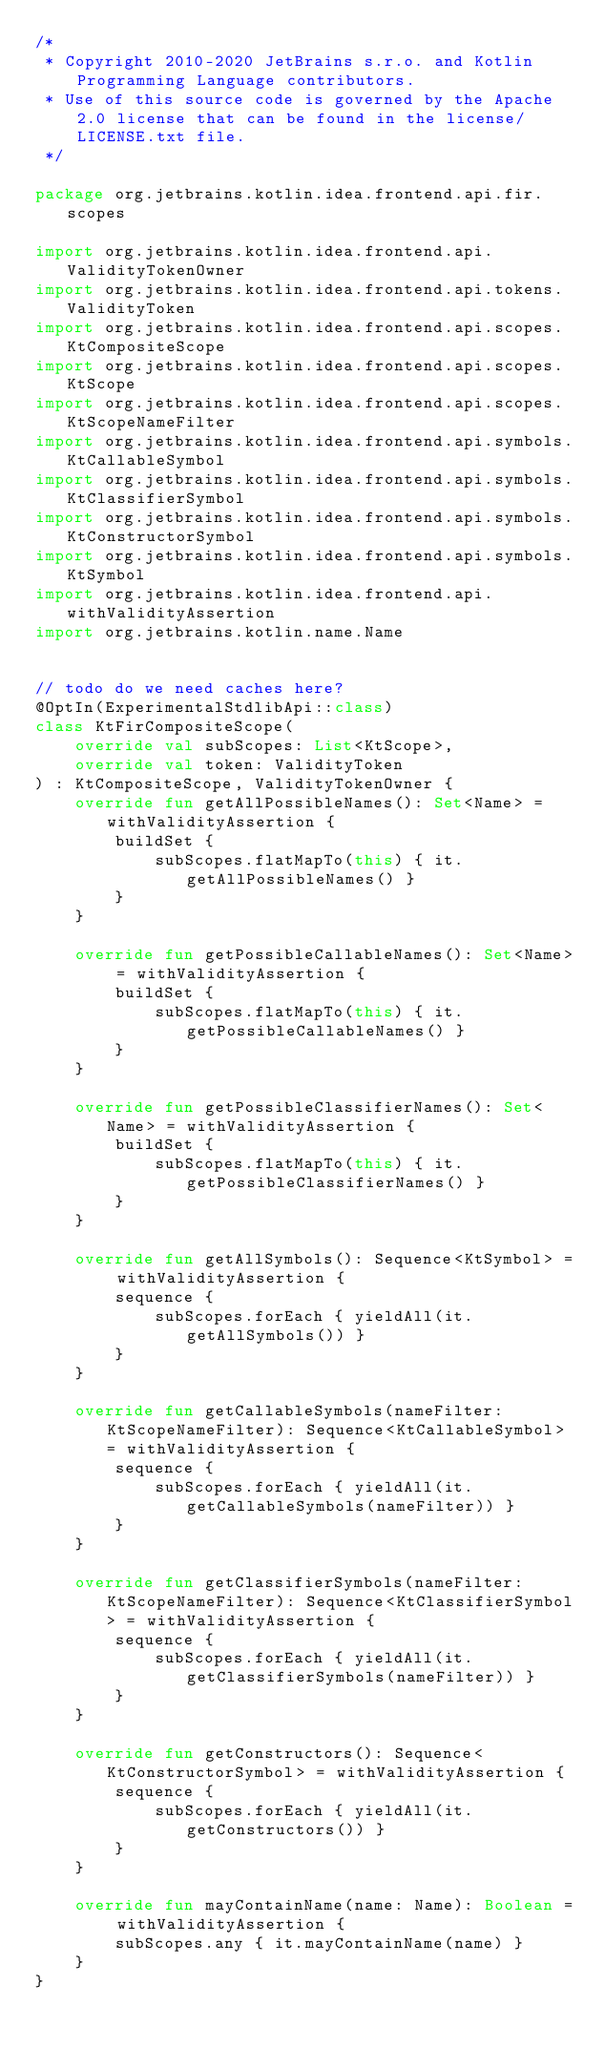Convert code to text. <code><loc_0><loc_0><loc_500><loc_500><_Kotlin_>/*
 * Copyright 2010-2020 JetBrains s.r.o. and Kotlin Programming Language contributors.
 * Use of this source code is governed by the Apache 2.0 license that can be found in the license/LICENSE.txt file.
 */

package org.jetbrains.kotlin.idea.frontend.api.fir.scopes

import org.jetbrains.kotlin.idea.frontend.api.ValidityTokenOwner
import org.jetbrains.kotlin.idea.frontend.api.tokens.ValidityToken
import org.jetbrains.kotlin.idea.frontend.api.scopes.KtCompositeScope
import org.jetbrains.kotlin.idea.frontend.api.scopes.KtScope
import org.jetbrains.kotlin.idea.frontend.api.scopes.KtScopeNameFilter
import org.jetbrains.kotlin.idea.frontend.api.symbols.KtCallableSymbol
import org.jetbrains.kotlin.idea.frontend.api.symbols.KtClassifierSymbol
import org.jetbrains.kotlin.idea.frontend.api.symbols.KtConstructorSymbol
import org.jetbrains.kotlin.idea.frontend.api.symbols.KtSymbol
import org.jetbrains.kotlin.idea.frontend.api.withValidityAssertion
import org.jetbrains.kotlin.name.Name


// todo do we need caches here?
@OptIn(ExperimentalStdlibApi::class)
class KtFirCompositeScope(
    override val subScopes: List<KtScope>,
    override val token: ValidityToken
) : KtCompositeScope, ValidityTokenOwner {
    override fun getAllPossibleNames(): Set<Name> = withValidityAssertion {
        buildSet {
            subScopes.flatMapTo(this) { it.getAllPossibleNames() }
        }
    }

    override fun getPossibleCallableNames(): Set<Name> = withValidityAssertion {
        buildSet {
            subScopes.flatMapTo(this) { it.getPossibleCallableNames() }
        }
    }

    override fun getPossibleClassifierNames(): Set<Name> = withValidityAssertion {
        buildSet {
            subScopes.flatMapTo(this) { it.getPossibleClassifierNames() }
        }
    }

    override fun getAllSymbols(): Sequence<KtSymbol> = withValidityAssertion {
        sequence {
            subScopes.forEach { yieldAll(it.getAllSymbols()) }
        }
    }

    override fun getCallableSymbols(nameFilter: KtScopeNameFilter): Sequence<KtCallableSymbol> = withValidityAssertion {
        sequence {
            subScopes.forEach { yieldAll(it.getCallableSymbols(nameFilter)) }
        }
    }

    override fun getClassifierSymbols(nameFilter: KtScopeNameFilter): Sequence<KtClassifierSymbol> = withValidityAssertion {
        sequence {
            subScopes.forEach { yieldAll(it.getClassifierSymbols(nameFilter)) }
        }
    }

    override fun getConstructors(): Sequence<KtConstructorSymbol> = withValidityAssertion {
        sequence {
            subScopes.forEach { yieldAll(it.getConstructors()) }
        }
    }

    override fun mayContainName(name: Name): Boolean = withValidityAssertion {
        subScopes.any { it.mayContainName(name) }
    }
}</code> 